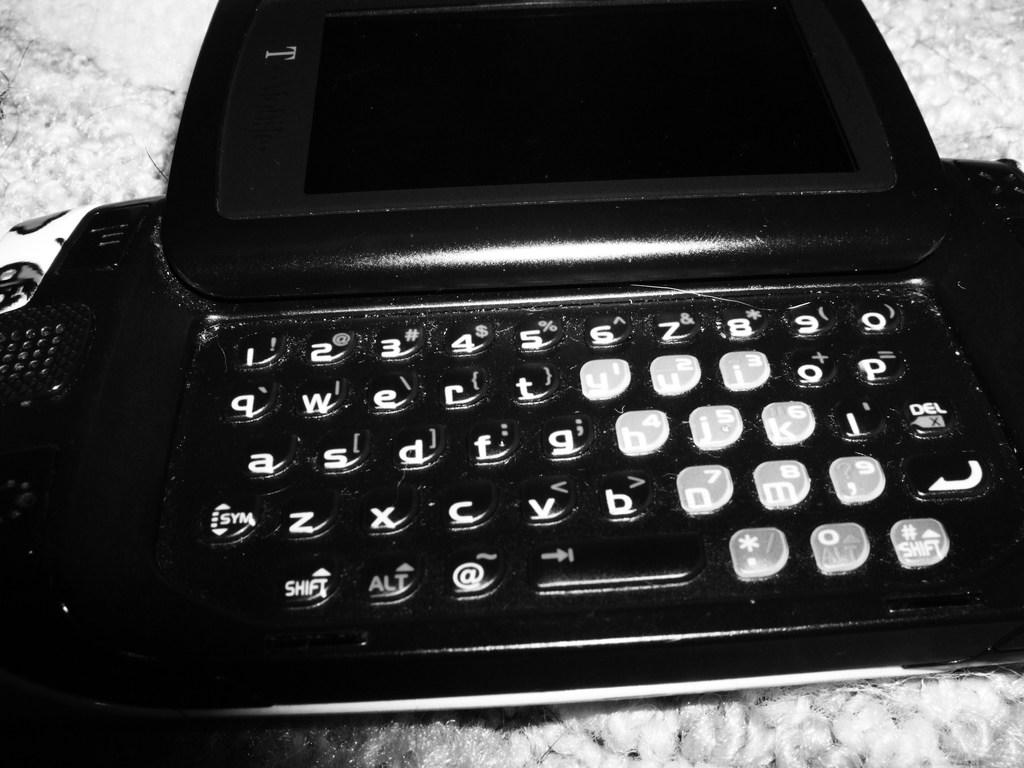<image>
Summarize the visual content of the image. A flip up phone device with an full qwerty keyboard. 